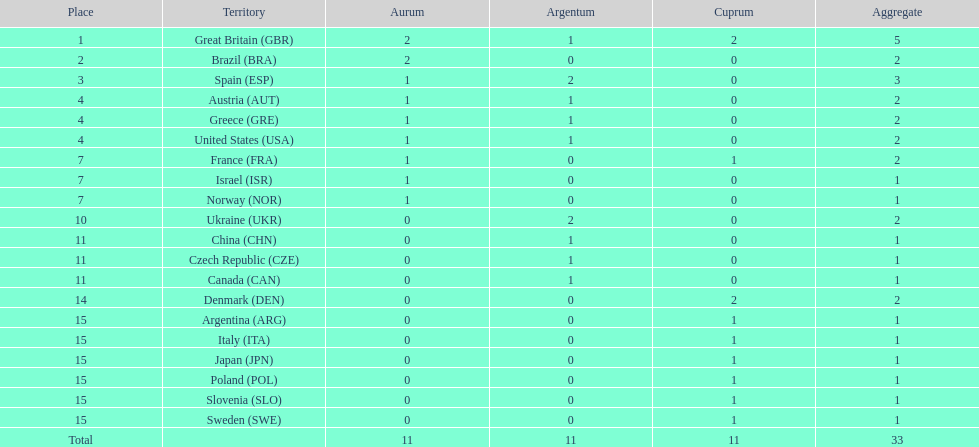What nation was next to great britain in total medal count? Spain. 